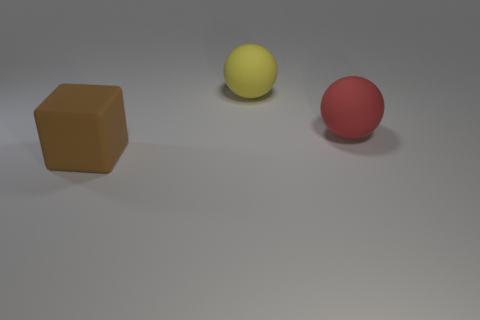What shape is the rubber thing that is on the right side of the big rubber sphere on the left side of the red object?
Your response must be concise. Sphere. Are there any big balls that are behind the thing on the right side of the ball behind the large red matte object?
Provide a succinct answer. Yes. What number of other objects are there of the same material as the red sphere?
Keep it short and to the point. 2. How many matte things are both on the left side of the big yellow ball and right of the big yellow rubber thing?
Your answer should be very brief. 0. The object behind the big matte thing right of the yellow rubber object is made of what material?
Your answer should be very brief. Rubber. There is a large yellow thing that is the same shape as the large red object; what material is it?
Offer a very short reply. Rubber. Are there any large matte spheres?
Provide a succinct answer. Yes. The large red object that is the same material as the brown thing is what shape?
Provide a succinct answer. Sphere. There is a large thing to the left of the yellow matte object; what is it made of?
Keep it short and to the point. Rubber. Is the color of the ball that is to the left of the big red rubber ball the same as the rubber block?
Ensure brevity in your answer.  No. 